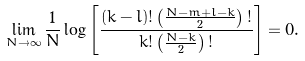<formula> <loc_0><loc_0><loc_500><loc_500>\lim _ { N \rightarrow \infty } \frac { 1 } { N } \log \left [ \frac { ( k - l ) ! \left ( \frac { N - m + l - k } { 2 } \right ) ! } { k ! \left ( \frac { N - k } { 2 } \right ) ! } \right ] = 0 .</formula> 